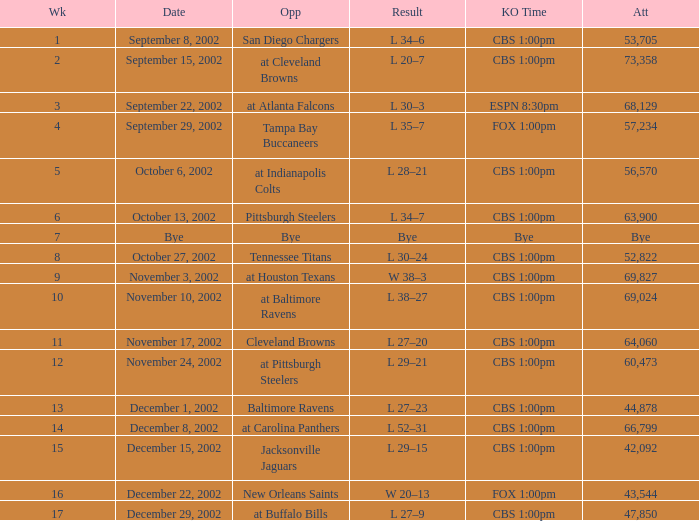What week was the opponent the San Diego Chargers? 1.0. 